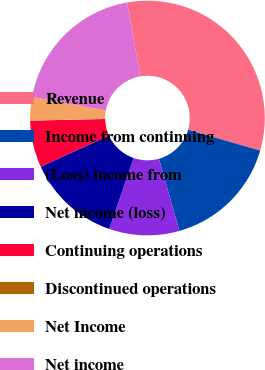<chart> <loc_0><loc_0><loc_500><loc_500><pie_chart><fcel>Revenue<fcel>Income from continuing<fcel>(Loss) income from<fcel>Net income (loss)<fcel>Continuing operations<fcel>Discontinued operations<fcel>Net Income<fcel>Net income<nl><fcel>32.25%<fcel>16.13%<fcel>9.68%<fcel>12.9%<fcel>6.45%<fcel>0.01%<fcel>3.23%<fcel>19.35%<nl></chart> 